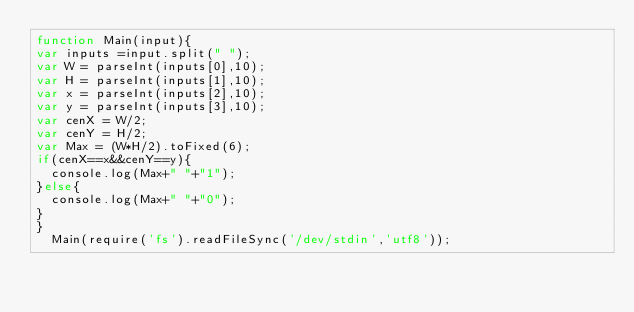<code> <loc_0><loc_0><loc_500><loc_500><_JavaScript_>function Main(input){ 
var inputs =input.split(" ");
var W = parseInt(inputs[0],10);
var H = parseInt(inputs[1],10);
var x = parseInt(inputs[2],10);
var y = parseInt(inputs[3],10);
var cenX = W/2;
var cenY = H/2;
var Max = (W*H/2).toFixed(6);
if(cenX==x&&cenY==y){
  console.log(Max+" "+"1");
}else{
  console.log(Max+" "+"0");
}
}
  Main(require('fs').readFileSync('/dev/stdin','utf8'));</code> 